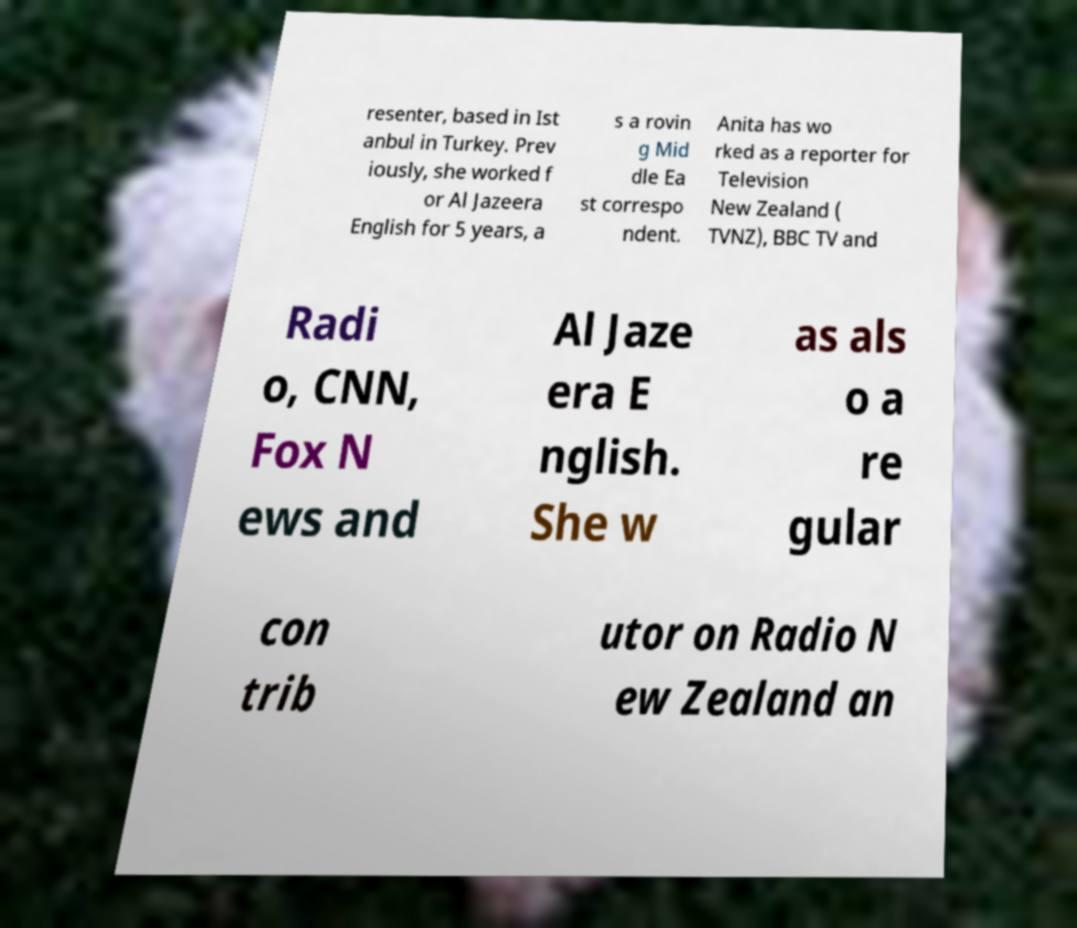Please read and relay the text visible in this image. What does it say? resenter, based in Ist anbul in Turkey. Prev iously, she worked f or Al Jazeera English for 5 years, a s a rovin g Mid dle Ea st correspo ndent. Anita has wo rked as a reporter for Television New Zealand ( TVNZ), BBC TV and Radi o, CNN, Fox N ews and Al Jaze era E nglish. She w as als o a re gular con trib utor on Radio N ew Zealand an 